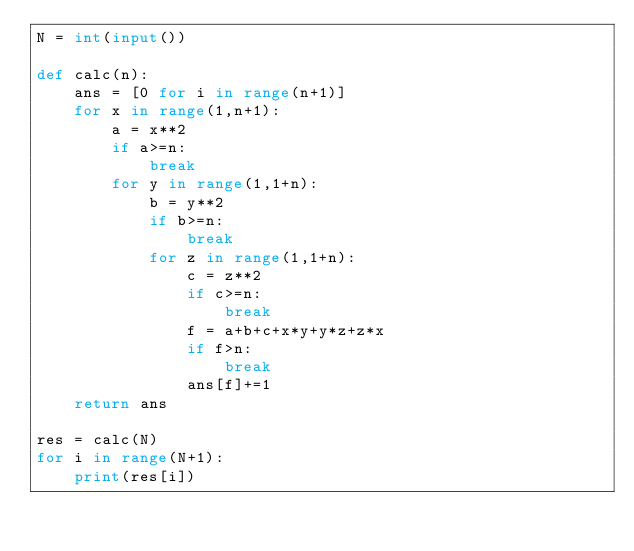Convert code to text. <code><loc_0><loc_0><loc_500><loc_500><_Python_>N = int(input())

def calc(n):
    ans = [0 for i in range(n+1)]
    for x in range(1,n+1):
        a = x**2
        if a>=n:
            break
        for y in range(1,1+n):
            b = y**2
            if b>=n:
                break
            for z in range(1,1+n):
                c = z**2
                if c>=n:
                    break
                f = a+b+c+x*y+y*z+z*x
                if f>n:
                    break
                ans[f]+=1
    return ans

res = calc(N)
for i in range(N+1):
    print(res[i])</code> 